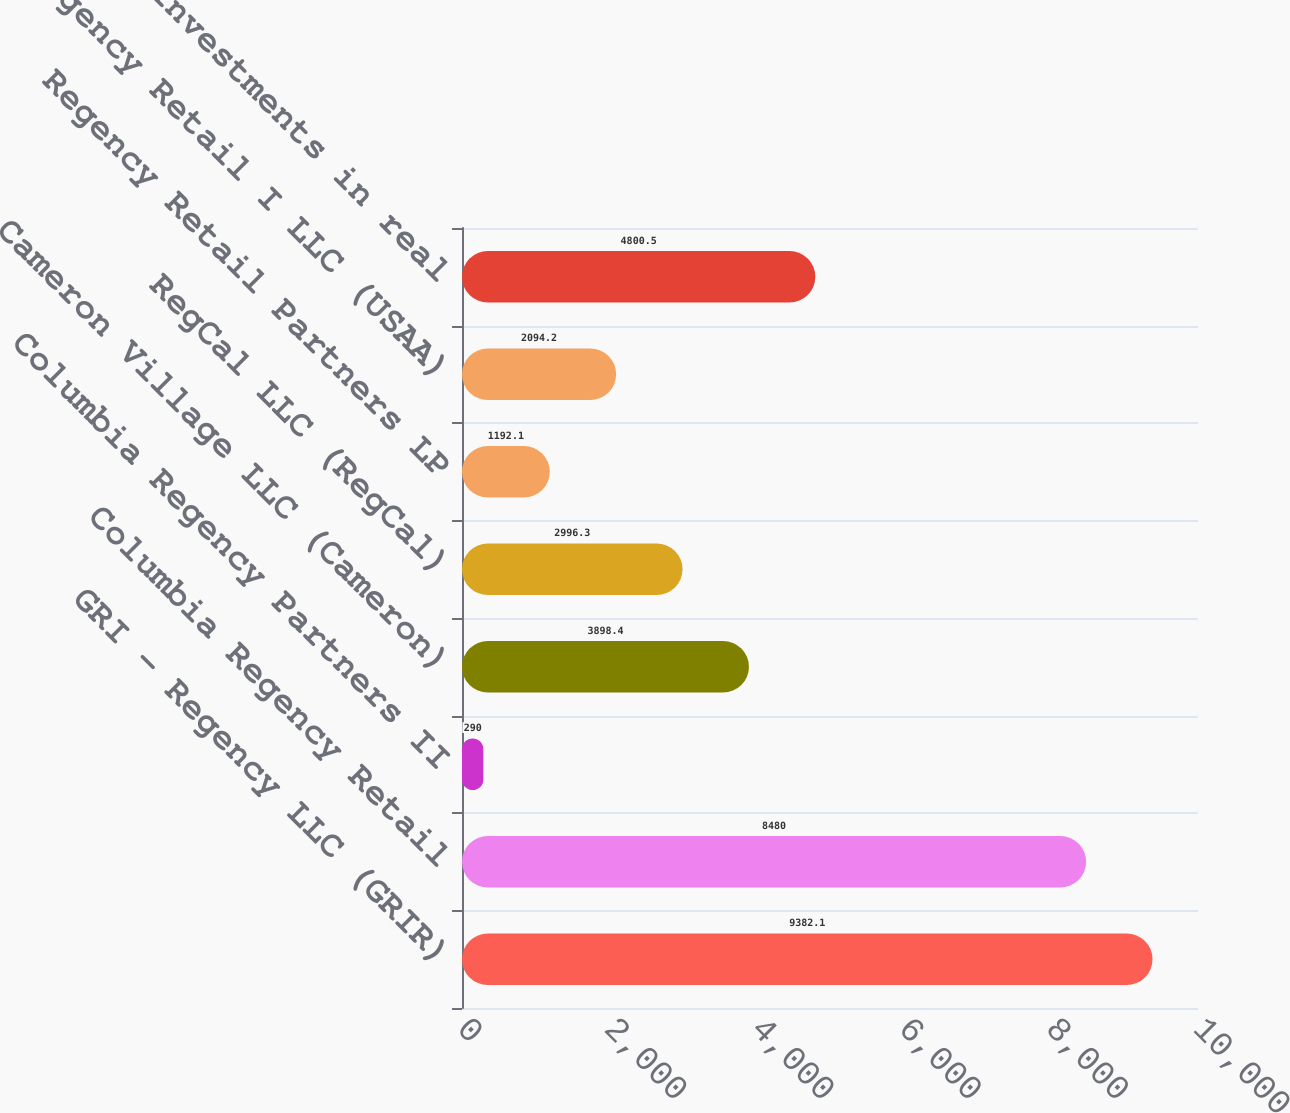<chart> <loc_0><loc_0><loc_500><loc_500><bar_chart><fcel>GRI - Regency LLC (GRIR)<fcel>Columbia Regency Retail<fcel>Columbia Regency Partners II<fcel>Cameron Village LLC (Cameron)<fcel>RegCal LLC (RegCal)<fcel>Regency Retail Partners LP<fcel>US Regency Retail I LLC (USAA)<fcel>Other investments in real<nl><fcel>9382.1<fcel>8480<fcel>290<fcel>3898.4<fcel>2996.3<fcel>1192.1<fcel>2094.2<fcel>4800.5<nl></chart> 